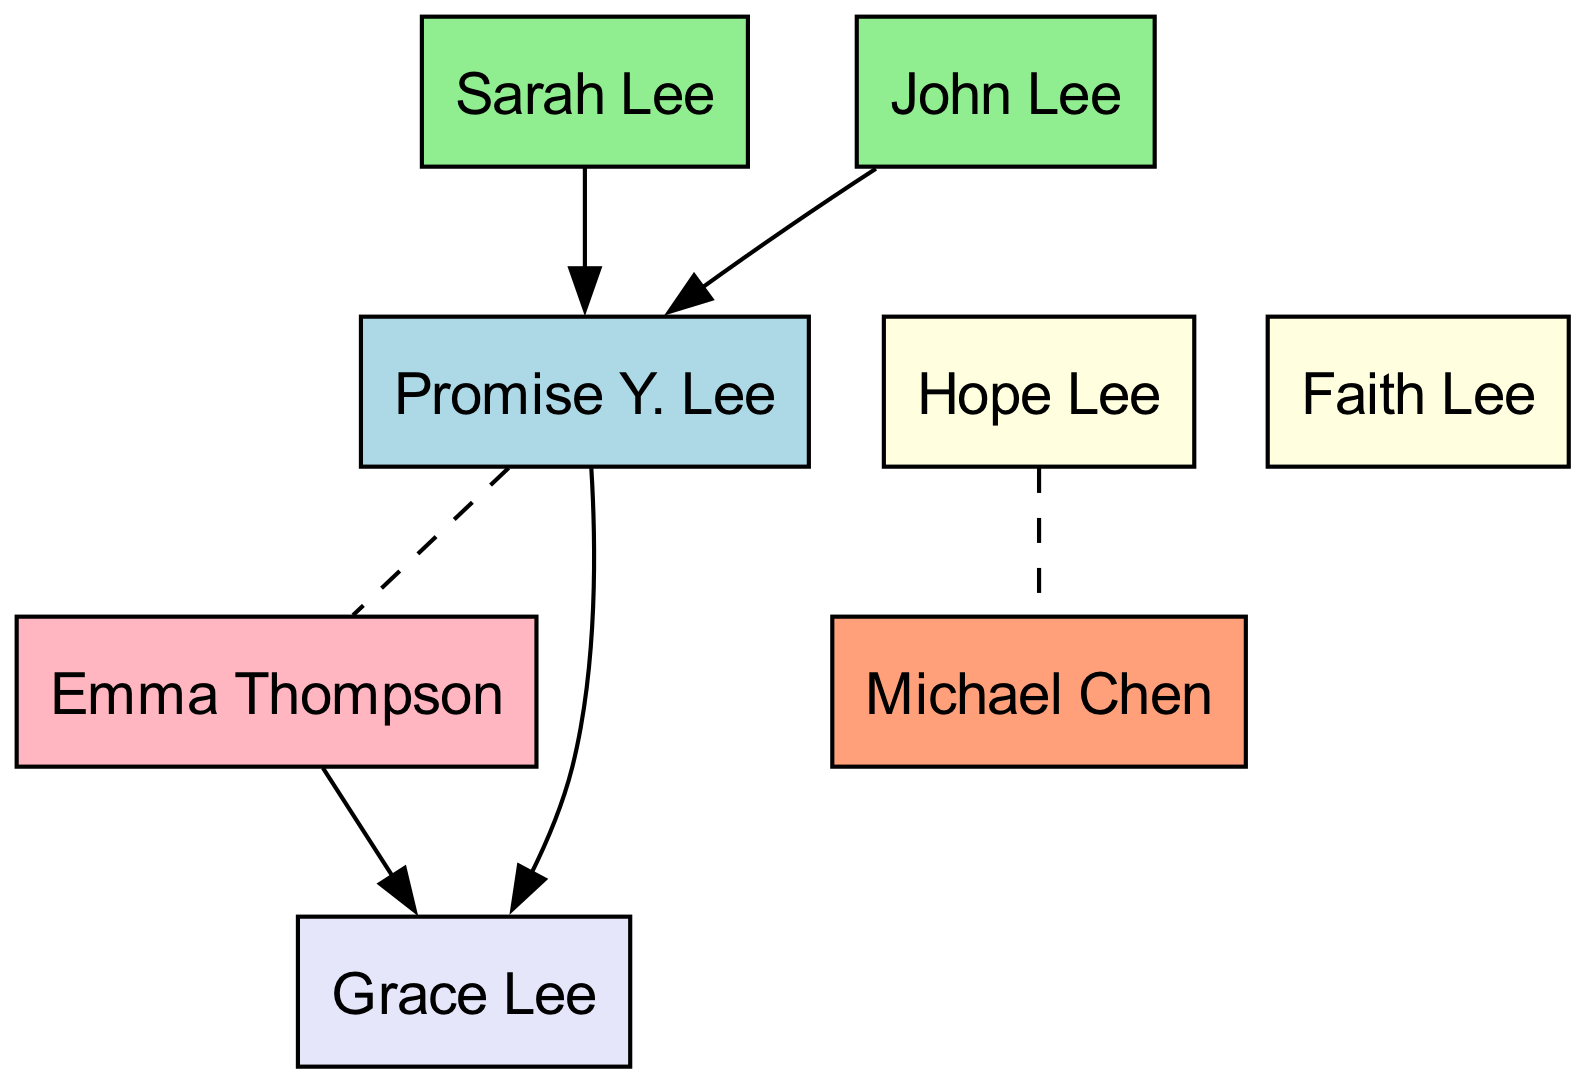What is the name of Promise Y. Lee's father? The diagram identifies "John Lee" as the father of Promise Y. Lee, who is positioned above Promise Y. Lee in the family tree.
Answer: John Lee How many sisters does Promise Y. Lee have? The diagram shows two sisters listed under Promise Y. Lee: "Hope Lee" and "Faith Lee." Thus, the total number of sisters is two.
Answer: 2 Who is the sibling of Promise Y. Lee married to? According to the diagram, Promise Y. Lee is married to "Emma Thompson," who is identified as the sister-in-law.
Answer: Emma Thompson What is the relationship between Michael Chen and Promise Y. Lee? The diagram shows that Michael Chen is the brother-in-law of Promise Y. Lee by virtue of being married to her sister, Hope Lee.
Answer: Brother-in-law How many children does Promise Y. Lee have? The diagram indicates that Promise Y. Lee has one child listed, which is "Grace Lee." Therefore, the number of children is one.
Answer: 1 Who are the parents of Grace Lee? The diagram states that Grace Lee is the child of Promise Y. Lee and Emma Thompson. Thus, both are named as her parents.
Answer: Promise Y. Lee and Emma Thompson Which sibling does Michael Chen belong to? Based on the diagram, Michael Chen is married to "Hope Lee," who is one of Promise Y. Lee's sisters. Thus, he belongs to her family.
Answer: Hope Lee How many in-laws are shown in the diagram? The diagram displays two in-laws: "Michael Chen" and "Emma Thompson," enumerating them clearly as relations through marriage. Thus, there are two in-laws.
Answer: 2 